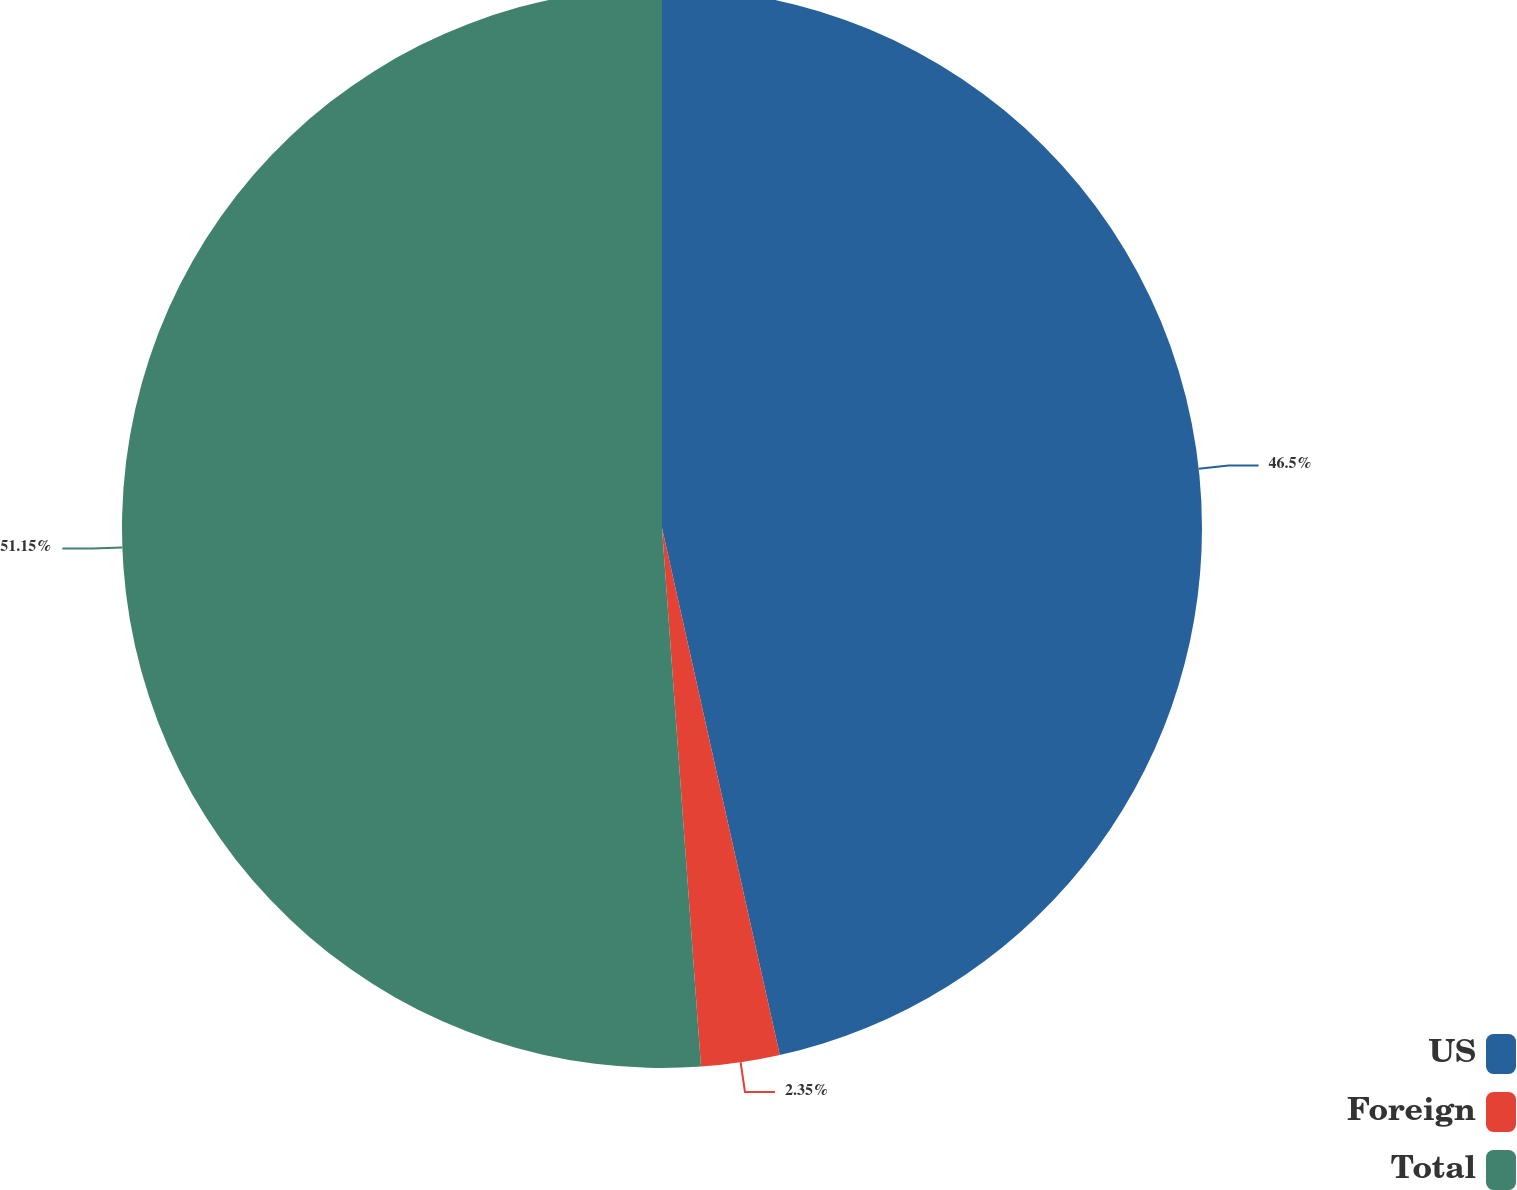Convert chart to OTSL. <chart><loc_0><loc_0><loc_500><loc_500><pie_chart><fcel>US<fcel>Foreign<fcel>Total<nl><fcel>46.5%<fcel>2.35%<fcel>51.15%<nl></chart> 